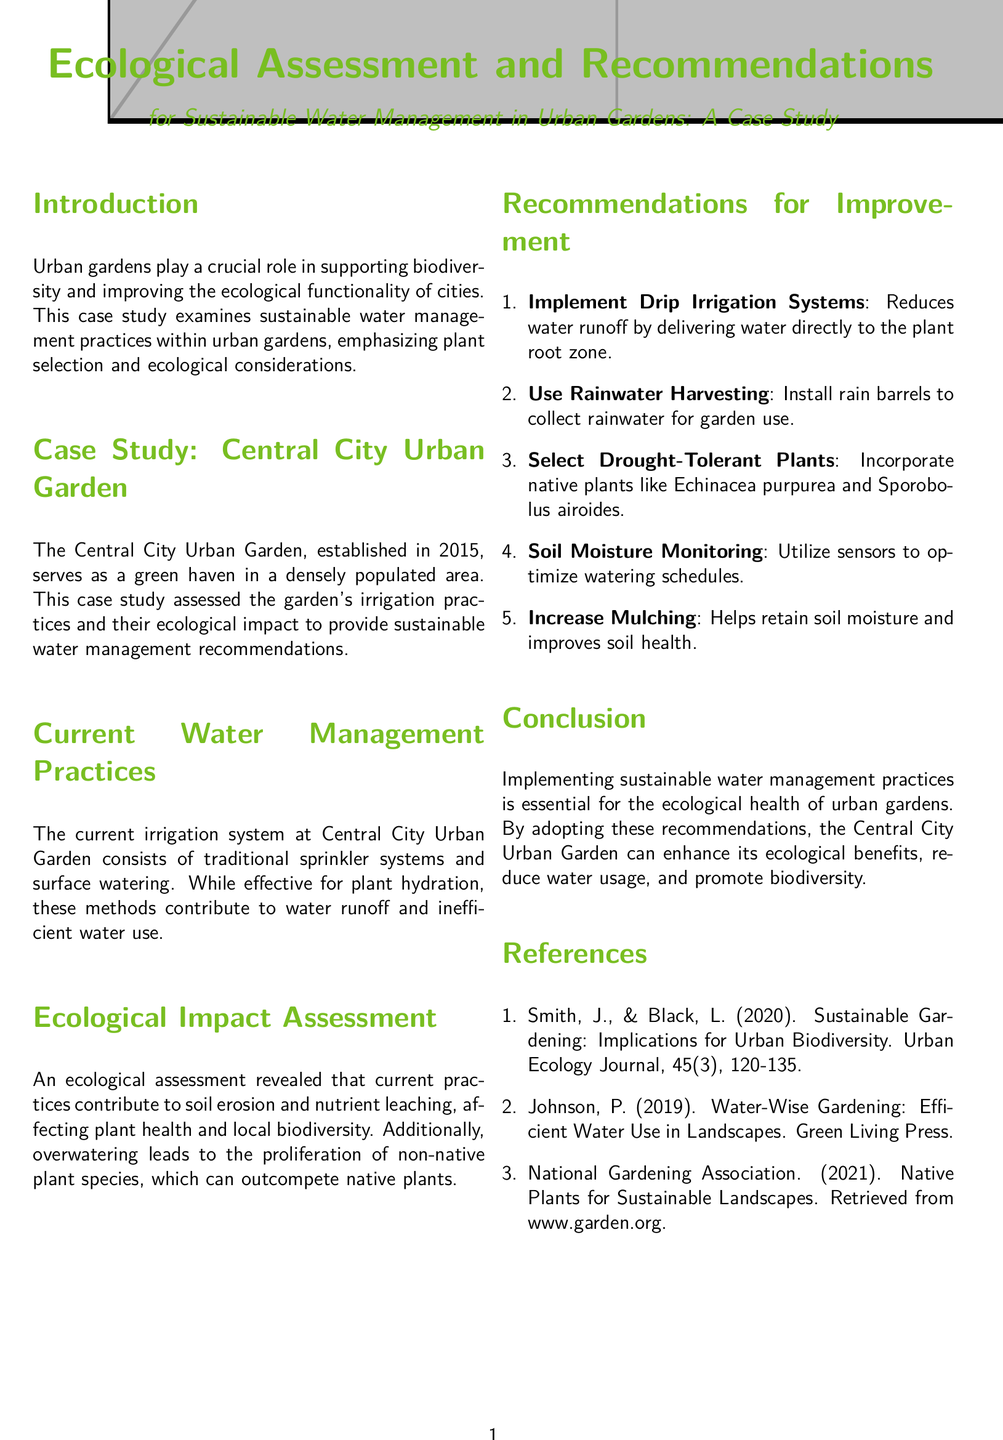What is the title of the case study? The title of the case study is provided in the document's center section.
Answer: Ecological Assessment and Recommendations for Sustainable Water Management in Urban Gardens: A Case Study In what year was the Central City Urban Garden established? The document states the establishment year of the garden under the case study section.
Answer: 2015 What type of irrigation system is currently used at the Central City Urban Garden? The document describes the current irrigation system used in the garden under the current practices section.
Answer: Traditional sprinkler systems and surface watering What is one of the recommendations for improving water management? This can be found in the recommendations section of the document, where various suggestions are listed.
Answer: Implement Drip Irrigation Systems Which native plant is recommended for drought tolerance? The document specifies some native plants suitable for drought-tolerant gardening in the recommendations section.
Answer: Echinacea purpurea What ecological issue was identified in the assessment? The assessment section outlines problems caused by current irrigation practices.
Answer: Soil erosion and nutrient leaching How many recommendations are listed for sustainable water management? The document enumerates the recommendations in a numbered list.
Answer: Five What is the primary ecological benefit of implementing sustainable practices? The conclusion section indicates the ecological benefits emphasized in the garden's practices.
Answer: Enhance its ecological benefits 